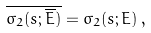Convert formula to latex. <formula><loc_0><loc_0><loc_500><loc_500>\overline { \sigma _ { 2 } ( s ; \overline { E } ) } = \sigma _ { 2 } ( s ; E ) \, ,</formula> 